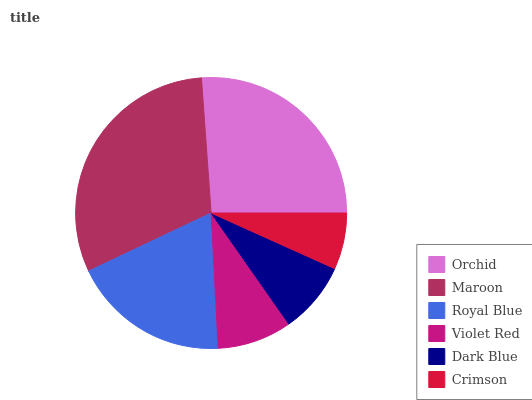Is Crimson the minimum?
Answer yes or no. Yes. Is Maroon the maximum?
Answer yes or no. Yes. Is Royal Blue the minimum?
Answer yes or no. No. Is Royal Blue the maximum?
Answer yes or no. No. Is Maroon greater than Royal Blue?
Answer yes or no. Yes. Is Royal Blue less than Maroon?
Answer yes or no. Yes. Is Royal Blue greater than Maroon?
Answer yes or no. No. Is Maroon less than Royal Blue?
Answer yes or no. No. Is Royal Blue the high median?
Answer yes or no. Yes. Is Violet Red the low median?
Answer yes or no. Yes. Is Dark Blue the high median?
Answer yes or no. No. Is Maroon the low median?
Answer yes or no. No. 